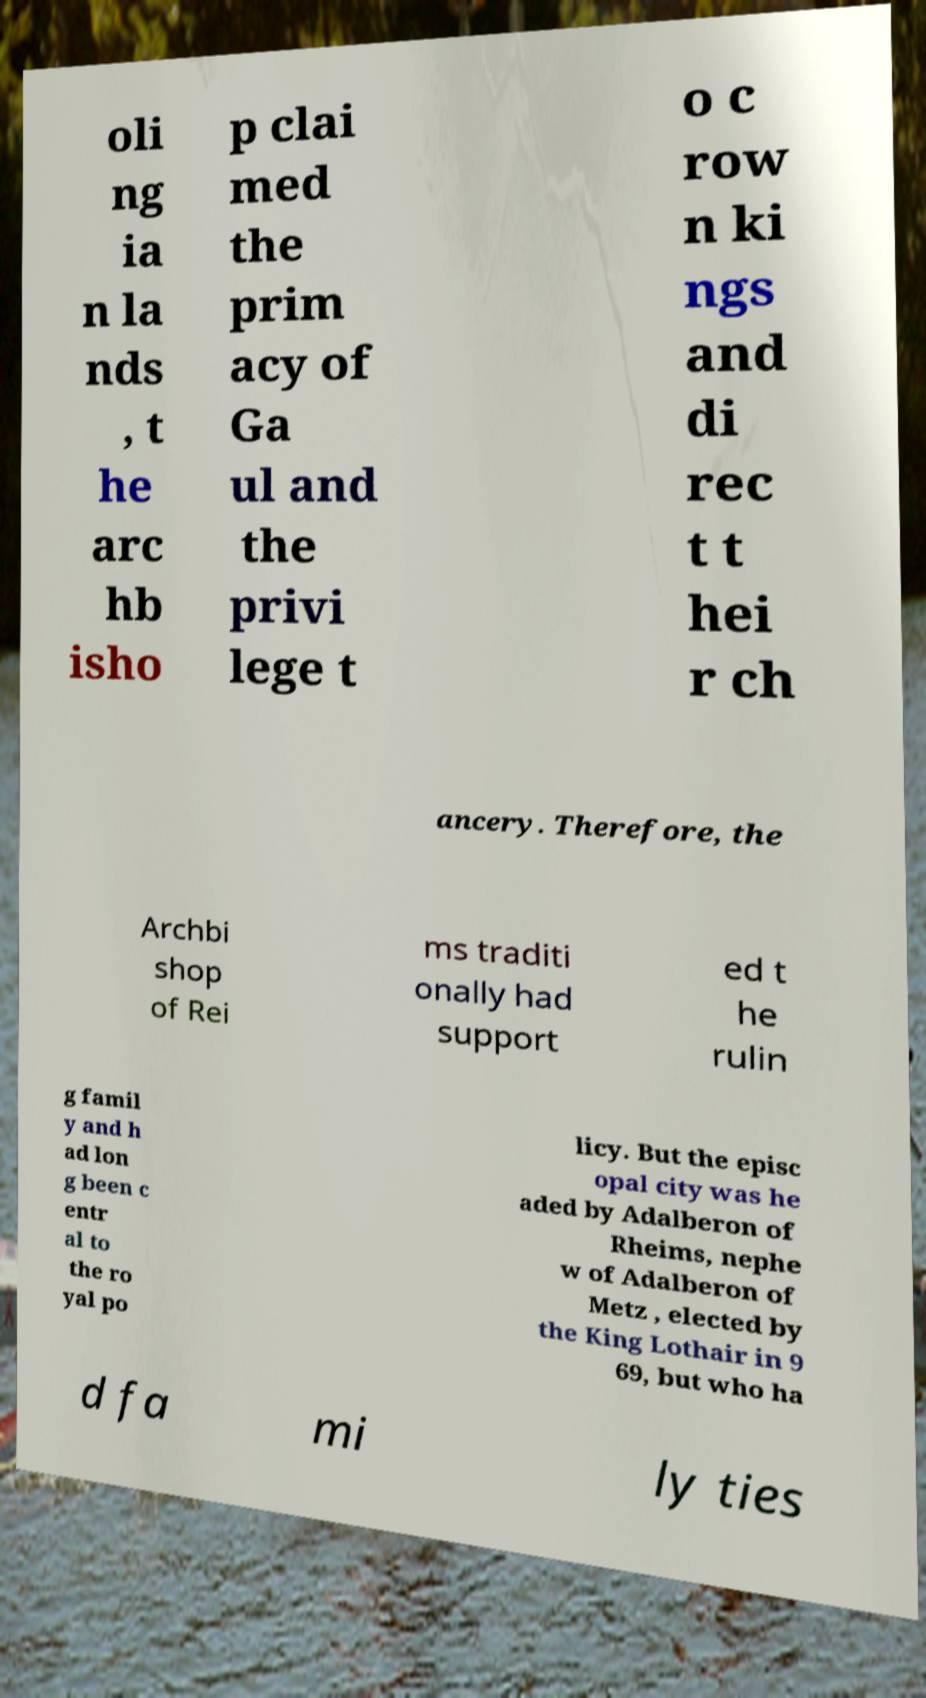I need the written content from this picture converted into text. Can you do that? oli ng ia n la nds , t he arc hb isho p clai med the prim acy of Ga ul and the privi lege t o c row n ki ngs and di rec t t hei r ch ancery. Therefore, the Archbi shop of Rei ms traditi onally had support ed t he rulin g famil y and h ad lon g been c entr al to the ro yal po licy. But the episc opal city was he aded by Adalberon of Rheims, nephe w of Adalberon of Metz , elected by the King Lothair in 9 69, but who ha d fa mi ly ties 